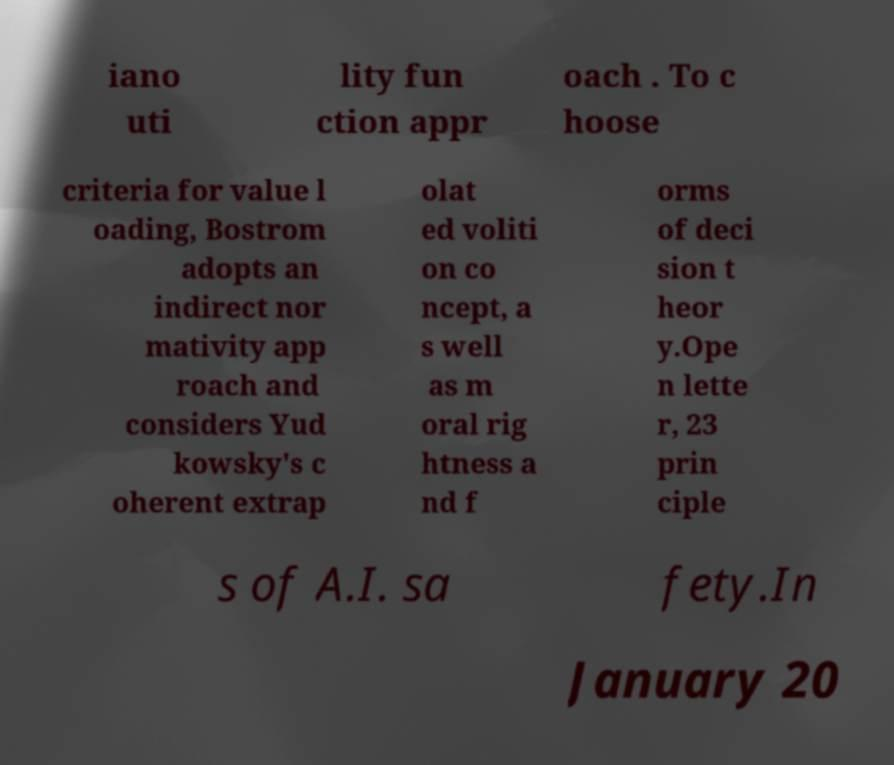Can you read and provide the text displayed in the image?This photo seems to have some interesting text. Can you extract and type it out for me? iano uti lity fun ction appr oach . To c hoose criteria for value l oading, Bostrom adopts an indirect nor mativity app roach and considers Yud kowsky's c oherent extrap olat ed voliti on co ncept, a s well as m oral rig htness a nd f orms of deci sion t heor y.Ope n lette r, 23 prin ciple s of A.I. sa fety.In January 20 